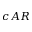Convert formula to latex. <formula><loc_0><loc_0><loc_500><loc_500>c A R</formula> 